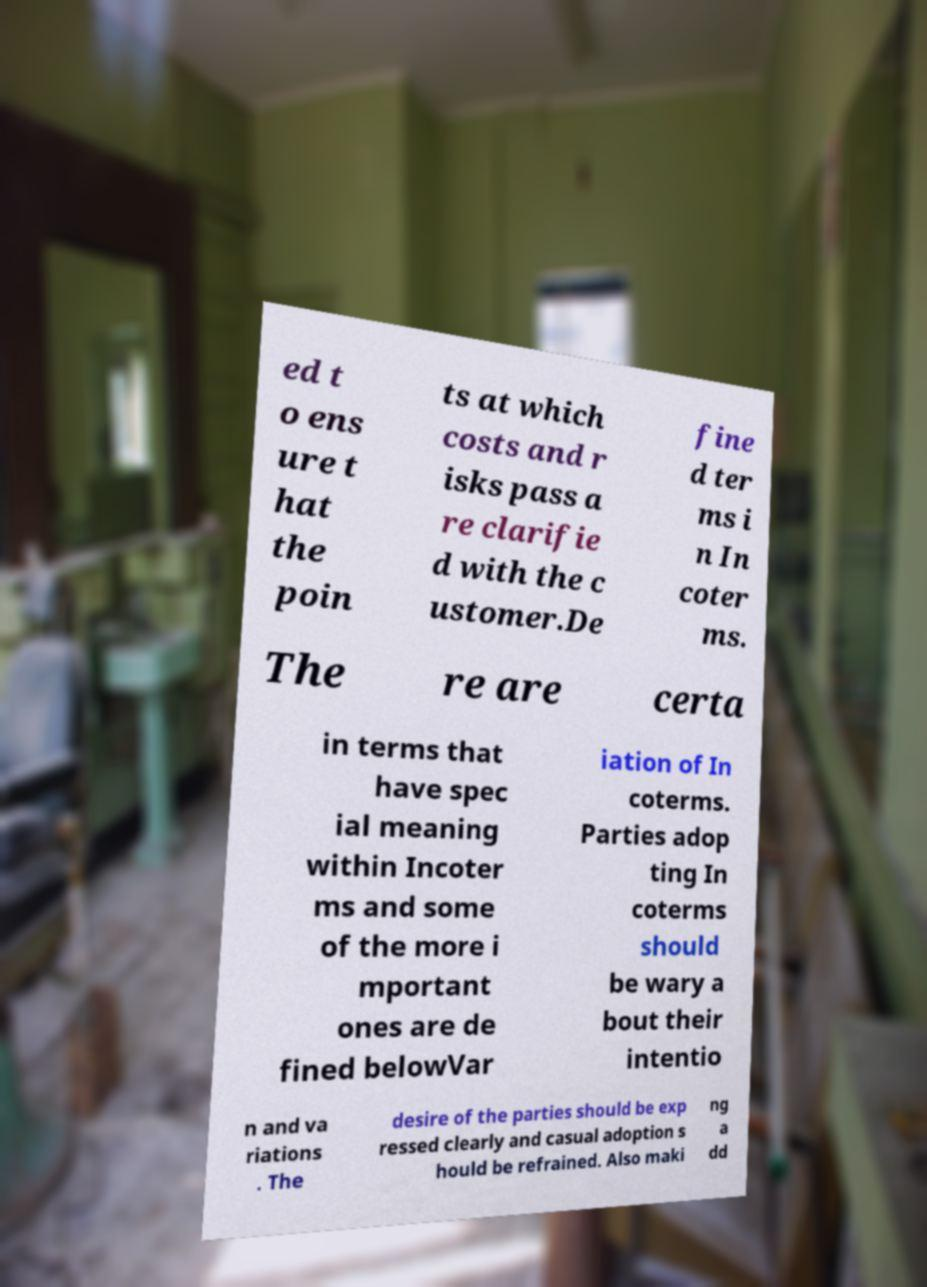Could you extract and type out the text from this image? ed t o ens ure t hat the poin ts at which costs and r isks pass a re clarifie d with the c ustomer.De fine d ter ms i n In coter ms. The re are certa in terms that have spec ial meaning within Incoter ms and some of the more i mportant ones are de fined belowVar iation of In coterms. Parties adop ting In coterms should be wary a bout their intentio n and va riations . The desire of the parties should be exp ressed clearly and casual adoption s hould be refrained. Also maki ng a dd 